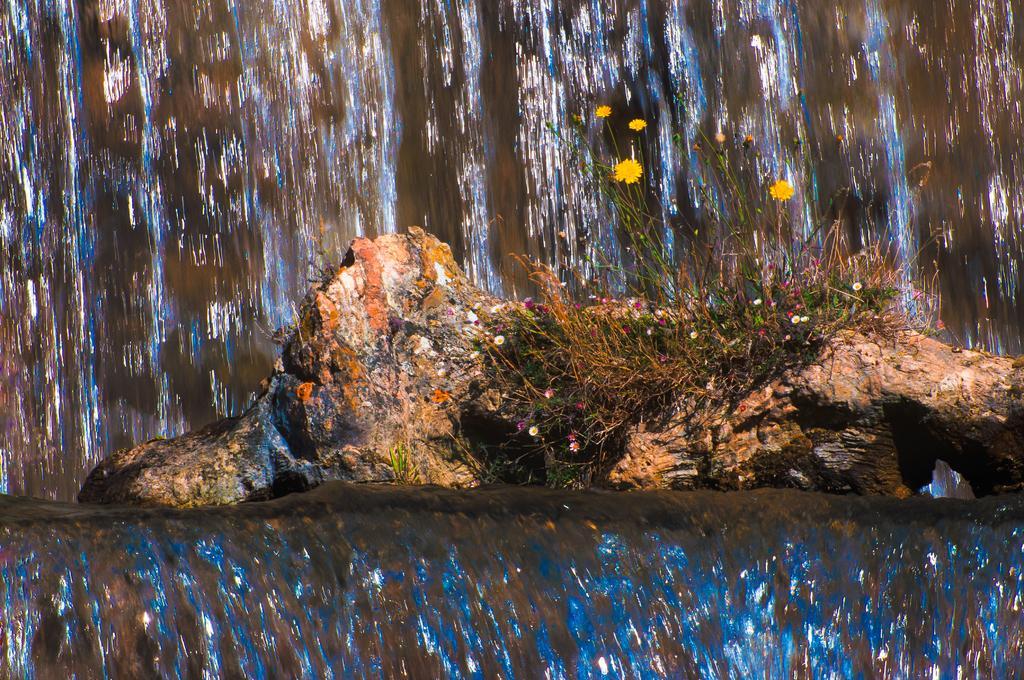Can you describe this image briefly? In this image we can see flowers and plants on the rock, there we can see a waterfall. 